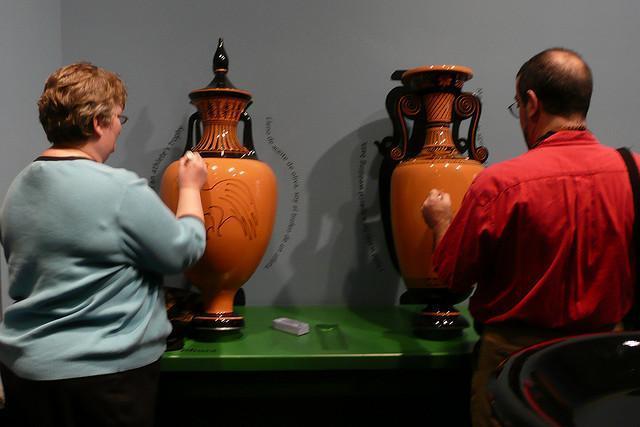How many people have glasses?
Give a very brief answer. 2. How many tables are in this room?
Give a very brief answer. 1. How many vases are displayed?
Give a very brief answer. 2. How many of the vases have lids?
Give a very brief answer. 1. How many people are in this picture?
Give a very brief answer. 2. How many people are in the photo?
Give a very brief answer. 2. How many vases can you see?
Give a very brief answer. 2. 